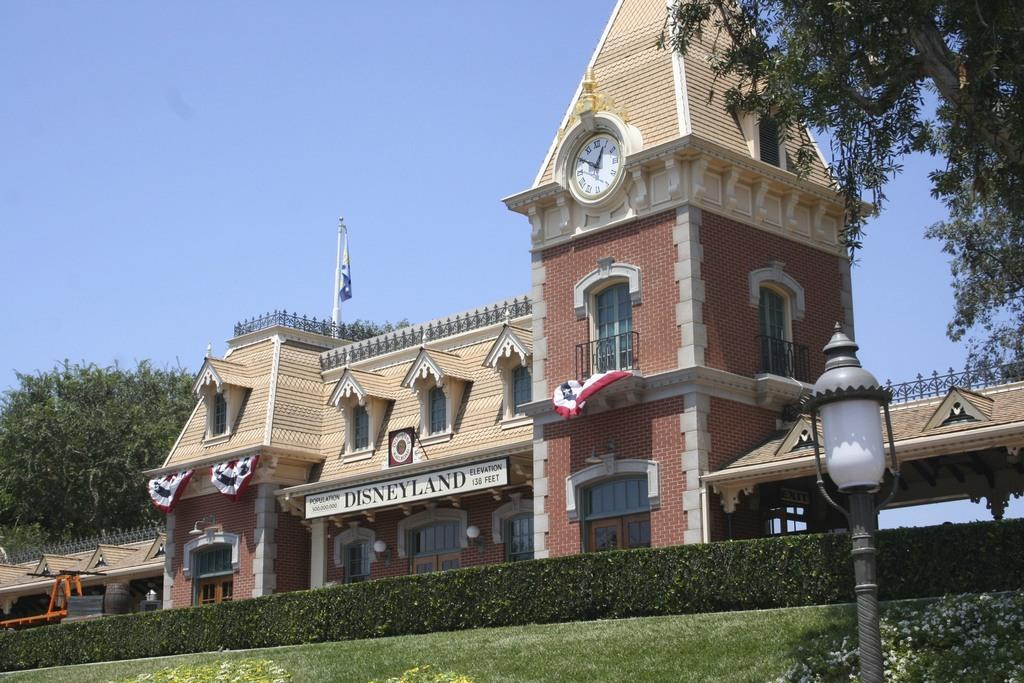<image>
Present a compact description of the photo's key features. A building that looks old fashioned with the word disneyland across the front. 